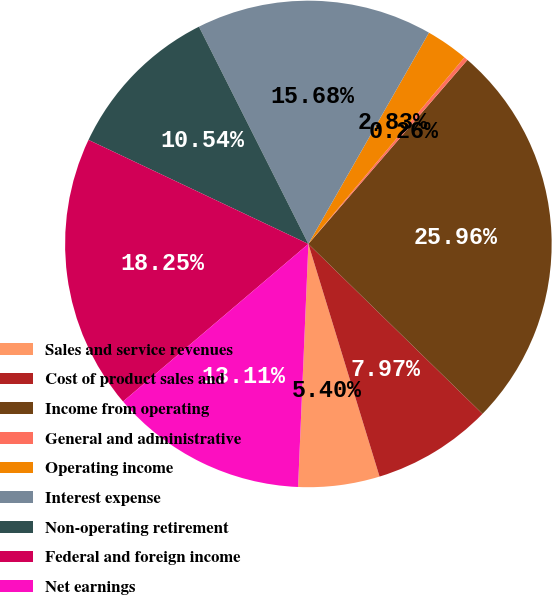Convert chart. <chart><loc_0><loc_0><loc_500><loc_500><pie_chart><fcel>Sales and service revenues<fcel>Cost of product sales and<fcel>Income from operating<fcel>General and administrative<fcel>Operating income<fcel>Interest expense<fcel>Non-operating retirement<fcel>Federal and foreign income<fcel>Net earnings<nl><fcel>5.4%<fcel>7.97%<fcel>25.96%<fcel>0.26%<fcel>2.83%<fcel>15.68%<fcel>10.54%<fcel>18.25%<fcel>13.11%<nl></chart> 